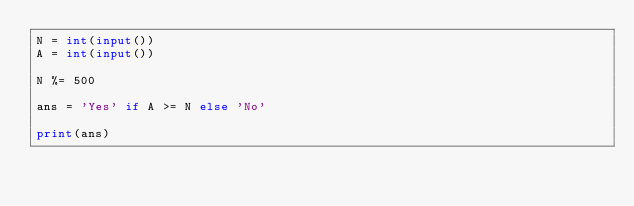<code> <loc_0><loc_0><loc_500><loc_500><_Python_>N = int(input())
A = int(input())

N %= 500

ans = 'Yes' if A >= N else 'No'

print(ans)
</code> 